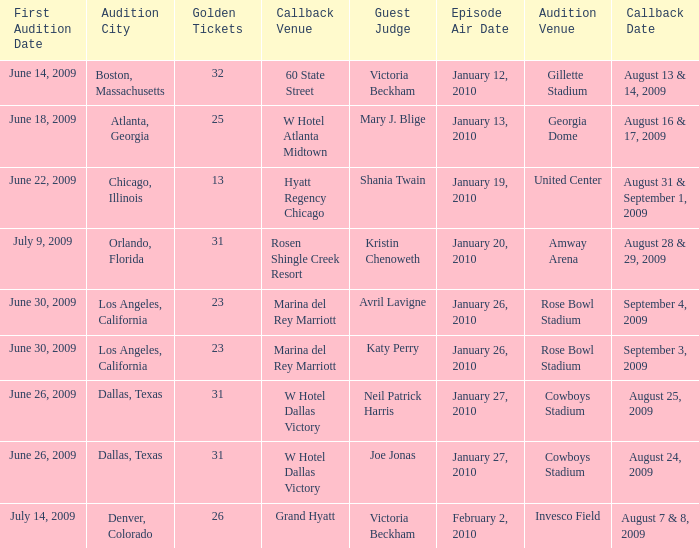Name the callback date for amway arena August 28 & 29, 2009. 